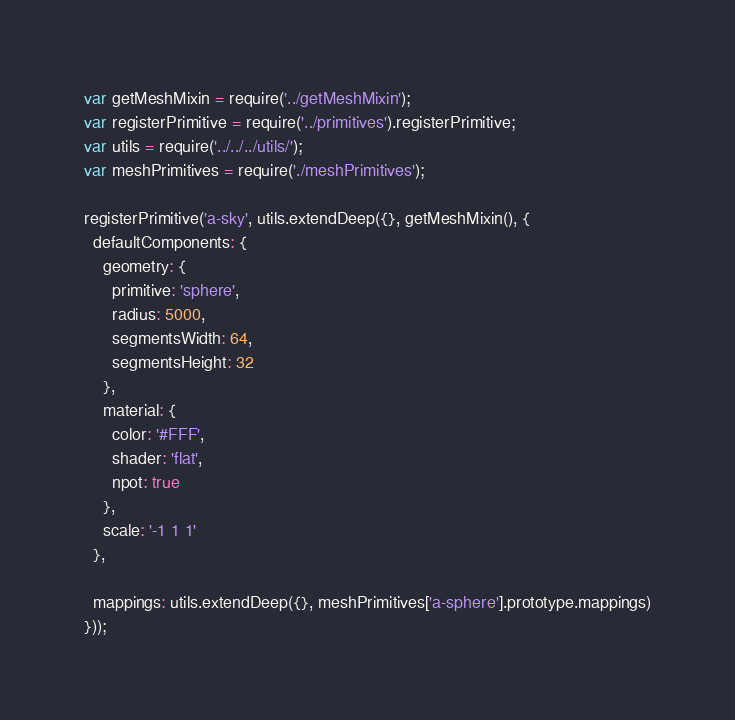<code> <loc_0><loc_0><loc_500><loc_500><_JavaScript_>var getMeshMixin = require('../getMeshMixin');
var registerPrimitive = require('../primitives').registerPrimitive;
var utils = require('../../../utils/');
var meshPrimitives = require('./meshPrimitives');

registerPrimitive('a-sky', utils.extendDeep({}, getMeshMixin(), {
  defaultComponents: {
    geometry: {
      primitive: 'sphere',
      radius: 5000,
      segmentsWidth: 64,
      segmentsHeight: 32
    },
    material: {
      color: '#FFF',
      shader: 'flat',
      npot: true
    },
    scale: '-1 1 1'
  },

  mappings: utils.extendDeep({}, meshPrimitives['a-sphere'].prototype.mappings)
}));
</code> 